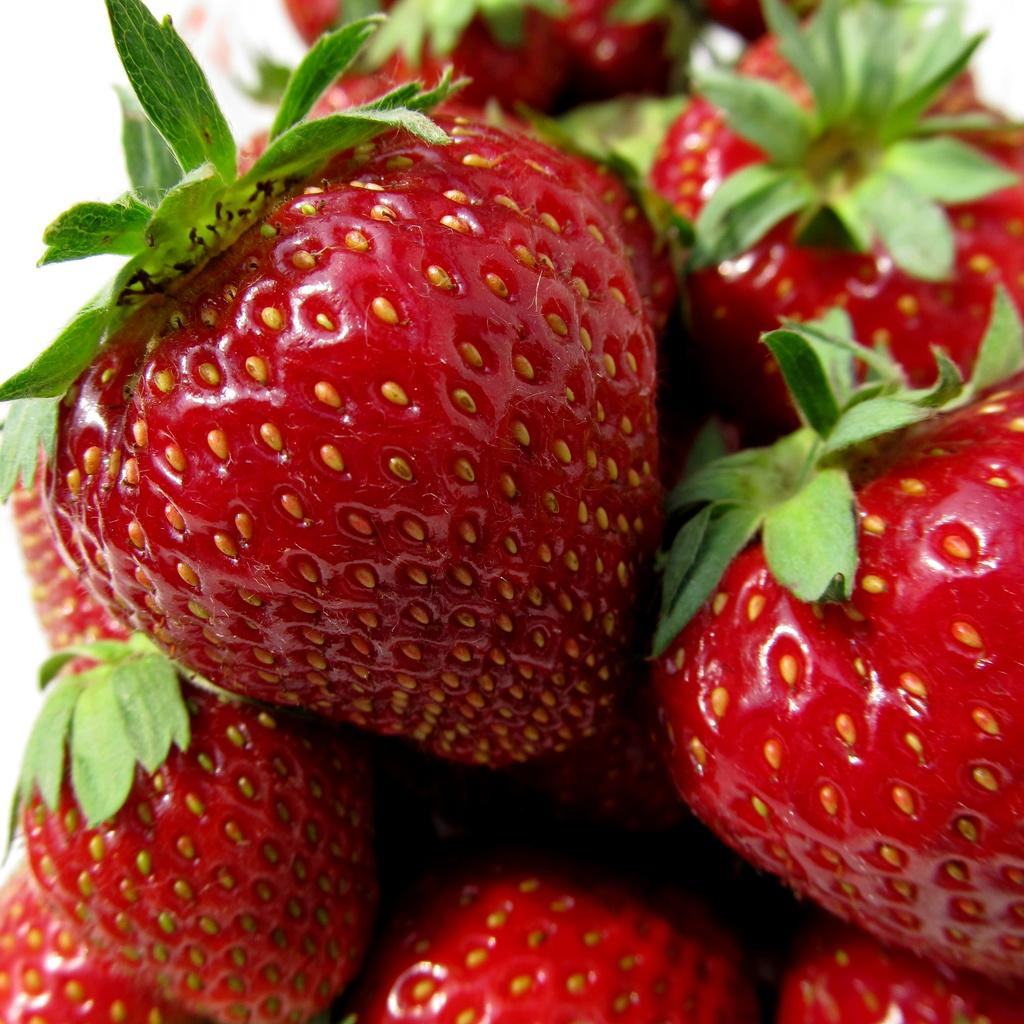What type of fruit is present in the image? There are strawberries in the image. How many fingers are touching the strawberries in the image? There are no fingers or hands visible in the image; it only shows strawberries. 